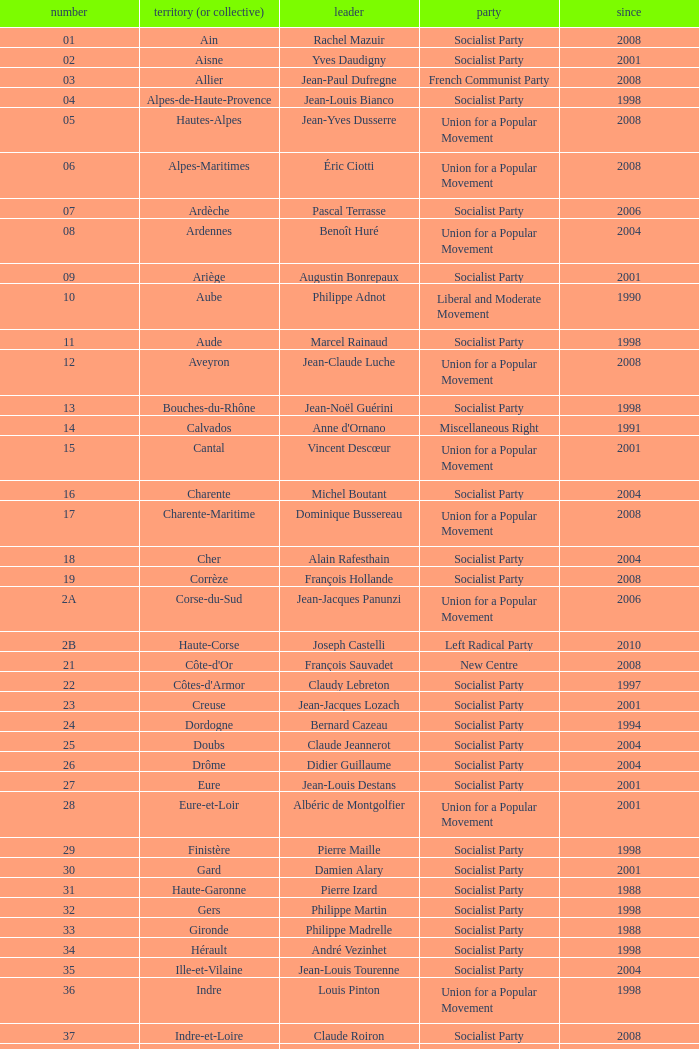Could you parse the entire table? {'header': ['number', 'territory (or collective)', 'leader', 'party', 'since'], 'rows': [['01', 'Ain', 'Rachel Mazuir', 'Socialist Party', '2008'], ['02', 'Aisne', 'Yves Daudigny', 'Socialist Party', '2001'], ['03', 'Allier', 'Jean-Paul Dufregne', 'French Communist Party', '2008'], ['04', 'Alpes-de-Haute-Provence', 'Jean-Louis Bianco', 'Socialist Party', '1998'], ['05', 'Hautes-Alpes', 'Jean-Yves Dusserre', 'Union for a Popular Movement', '2008'], ['06', 'Alpes-Maritimes', 'Éric Ciotti', 'Union for a Popular Movement', '2008'], ['07', 'Ardèche', 'Pascal Terrasse', 'Socialist Party', '2006'], ['08', 'Ardennes', 'Benoît Huré', 'Union for a Popular Movement', '2004'], ['09', 'Ariège', 'Augustin Bonrepaux', 'Socialist Party', '2001'], ['10', 'Aube', 'Philippe Adnot', 'Liberal and Moderate Movement', '1990'], ['11', 'Aude', 'Marcel Rainaud', 'Socialist Party', '1998'], ['12', 'Aveyron', 'Jean-Claude Luche', 'Union for a Popular Movement', '2008'], ['13', 'Bouches-du-Rhône', 'Jean-Noël Guérini', 'Socialist Party', '1998'], ['14', 'Calvados', "Anne d'Ornano", 'Miscellaneous Right', '1991'], ['15', 'Cantal', 'Vincent Descœur', 'Union for a Popular Movement', '2001'], ['16', 'Charente', 'Michel Boutant', 'Socialist Party', '2004'], ['17', 'Charente-Maritime', 'Dominique Bussereau', 'Union for a Popular Movement', '2008'], ['18', 'Cher', 'Alain Rafesthain', 'Socialist Party', '2004'], ['19', 'Corrèze', 'François Hollande', 'Socialist Party', '2008'], ['2A', 'Corse-du-Sud', 'Jean-Jacques Panunzi', 'Union for a Popular Movement', '2006'], ['2B', 'Haute-Corse', 'Joseph Castelli', 'Left Radical Party', '2010'], ['21', "Côte-d'Or", 'François Sauvadet', 'New Centre', '2008'], ['22', "Côtes-d'Armor", 'Claudy Lebreton', 'Socialist Party', '1997'], ['23', 'Creuse', 'Jean-Jacques Lozach', 'Socialist Party', '2001'], ['24', 'Dordogne', 'Bernard Cazeau', 'Socialist Party', '1994'], ['25', 'Doubs', 'Claude Jeannerot', 'Socialist Party', '2004'], ['26', 'Drôme', 'Didier Guillaume', 'Socialist Party', '2004'], ['27', 'Eure', 'Jean-Louis Destans', 'Socialist Party', '2001'], ['28', 'Eure-et-Loir', 'Albéric de Montgolfier', 'Union for a Popular Movement', '2001'], ['29', 'Finistère', 'Pierre Maille', 'Socialist Party', '1998'], ['30', 'Gard', 'Damien Alary', 'Socialist Party', '2001'], ['31', 'Haute-Garonne', 'Pierre Izard', 'Socialist Party', '1988'], ['32', 'Gers', 'Philippe Martin', 'Socialist Party', '1998'], ['33', 'Gironde', 'Philippe Madrelle', 'Socialist Party', '1988'], ['34', 'Hérault', 'André Vezinhet', 'Socialist Party', '1998'], ['35', 'Ille-et-Vilaine', 'Jean-Louis Tourenne', 'Socialist Party', '2004'], ['36', 'Indre', 'Louis Pinton', 'Union for a Popular Movement', '1998'], ['37', 'Indre-et-Loire', 'Claude Roiron', 'Socialist Party', '2008'], ['38', 'Isère', 'André Vallini', 'Socialist Party', '2001'], ['39', 'Jura', 'Jean Raquin', 'Miscellaneous Right', '2008'], ['40', 'Landes', 'Henri Emmanuelli', 'Socialist Party', '1982'], ['41', 'Loir-et-Cher', 'Maurice Leroy', 'New Centre', '2004'], ['42', 'Loire', 'Bernard Bonne', 'Union for a Popular Movement', '2008'], ['43', 'Haute-Loire', 'Gérard Roche', 'Union for a Popular Movement', '2004'], ['44', 'Loire-Atlantique', 'Patrick Mareschal', 'Socialist Party', '2004'], ['45', 'Loiret', 'Éric Doligé', 'Union for a Popular Movement', '1994'], ['46', 'Lot', 'Gérard Miquel', 'Socialist Party', '2004'], ['47', 'Lot-et-Garonne', 'Pierre Camani', 'Socialist Party', '2008'], ['48', 'Lozère', 'Jean-Paul Pourquier', 'Union for a Popular Movement', '2004'], ['49', 'Maine-et-Loire', 'Christophe Béchu', 'Union for a Popular Movement', '2004'], ['50', 'Manche', 'Jean-François Le Grand', 'Union for a Popular Movement', '1998'], ['51', 'Marne', 'René-Paul Savary', 'Union for a Popular Movement', '2003'], ['52', 'Haute-Marne', 'Bruno Sido', 'Union for a Popular Movement', '1998'], ['53', 'Mayenne', 'Jean Arthuis', 'Miscellaneous Centre', '1992'], ['54', 'Meurthe-et-Moselle', 'Michel Dinet', 'Socialist Party', '1998'], ['55', 'Meuse', 'Christian Namy', 'Miscellaneous Right', '2004'], ['56', 'Morbihan', 'Joseph-François Kerguéris', 'Democratic Movement', '2004'], ['57', 'Moselle', 'Philippe Leroy', 'Union for a Popular Movement', '1992'], ['58', 'Nièvre', 'Marcel Charmant', 'Socialist Party', '2001'], ['59', 'Nord', 'Patrick Kanner', 'Socialist Party', '1998'], ['60', 'Oise', 'Yves Rome', 'Socialist Party', '2004'], ['61', 'Orne', 'Alain Lambert', 'Union for a Popular Movement', '2007'], ['62', 'Pas-de-Calais', 'Dominique Dupilet', 'Socialist Party', '2004'], ['63', 'Puy-de-Dôme', 'Jean-Yves Gouttebel', 'Socialist Party', '2004'], ['64', 'Pyrénées-Atlantiques', 'Jean Castaings', 'Union for a Popular Movement', '2008'], ['65', 'Hautes-Pyrénées', 'Josette Durrieu', 'Socialist Party', '2008'], ['66', 'Pyrénées-Orientales', 'Christian Bourquin', 'Socialist Party', '1998'], ['67', 'Bas-Rhin', 'Guy-Dominique Kennel', 'Union for a Popular Movement', '2008'], ['68', 'Haut-Rhin', 'Charles Buttner', 'Union for a Popular Movement', '2004'], ['69', 'Rhône', 'Michel Mercier', 'Miscellaneous Centre', '1990'], ['70', 'Haute-Saône', 'Yves Krattinger', 'Socialist Party', '2002'], ['71', 'Saône-et-Loire', 'Arnaud Montebourg', 'Socialist Party', '2008'], ['72', 'Sarthe', 'Roland du Luart', 'Union for a Popular Movement', '1998'], ['73', 'Savoie', 'Hervé Gaymard', 'Union for a Popular Movement', '2008'], ['74', 'Haute-Savoie', 'Christian Monteil', 'Miscellaneous Right', '2008'], ['75', 'Paris', 'Bertrand Delanoë', 'Socialist Party', '2001'], ['76', 'Seine-Maritime', 'Didier Marie', 'Socialist Party', '2004'], ['77', 'Seine-et-Marne', 'Vincent Eblé', 'Socialist Party', '2004'], ['78', 'Yvelines', 'Pierre Bédier', 'Union for a Popular Movement', '2005'], ['79', 'Deux-Sèvres', 'Éric Gautier', 'Socialist Party', '2008'], ['80', 'Somme', 'Christian Manable', 'Socialist Party', '2008'], ['81', 'Tarn', 'Thierry Carcenac', 'Socialist Party', '1991'], ['82', 'Tarn-et-Garonne', 'Jean-Michel Baylet', 'Left Radical Party', '1986'], ['83', 'Var', 'Horace Lanfranchi', 'Union for a Popular Movement', '2002'], ['84', 'Vaucluse', 'Claude Haut', 'Socialist Party', '2001'], ['85', 'Vendée', 'Philippe de Villiers', 'Movement for France', '1988'], ['86', 'Vienne', 'Claude Bertaud', 'Union for a Popular Movement', '2008'], ['87', 'Haute-Vienne', 'Marie-Françoise Pérol-Dumont', 'Socialist Party', '2004'], ['88', 'Vosges', 'Christian Poncelet', 'Union for a Popular Movement', '1976'], ['89', 'Yonne', 'Jean-Marie Rolland', 'Union for a Popular Movement', '2008'], ['90', 'Territoire de Belfort', 'Yves Ackermann', 'Socialist Party', '2004'], ['91', 'Essonne', 'Michel Berson', 'Socialist Party', '1998'], ['92', 'Hauts-de-Seine', 'Patrick Devedjian', 'Union for a Popular Movement', '2007'], ['93', 'Seine-Saint-Denis', 'Claude Bartolone', 'Socialist Party', '2008'], ['94', 'Val-de-Marne', 'Christian Favier', 'French Communist Party', '2001'], ['95', 'Val-d’Oise', 'Arnaud Bazin', 'Union for a Popular Movement', '2011'], ['971', 'Guadeloupe', 'Jacques Gillot', 'United Guadeloupe, Socialism and Realities', '2001'], ['972', 'Martinique', 'Claude Lise', 'Martinican Democratic Rally', '1992'], ['973', 'Guyane', 'Alain Tien-Liong', 'Miscellaneous Left', '2008'], ['974', 'Réunion', 'Nassimah Dindar', 'Union for a Popular Movement', '2004'], ['975', 'Saint-Pierre-et-Miquelon (overseas collect.)', 'Stéphane Artano', 'Archipelago Tomorrow', '2006'], ['976', 'Mayotte (overseas collect.)', 'Ahmed Attoumani Douchina', 'Union for a Popular Movement', '2008']]} Who is the president from the Union for a Popular Movement party that represents the Hautes-Alpes department? Jean-Yves Dusserre. 